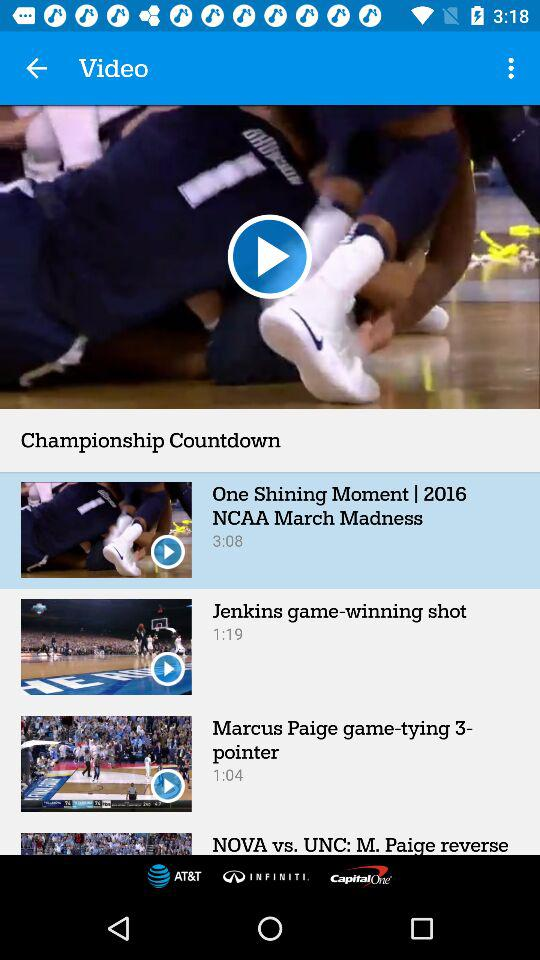What is the selected video? The selected video is "One Shining Moment | 2016 NCAA March Madness". 